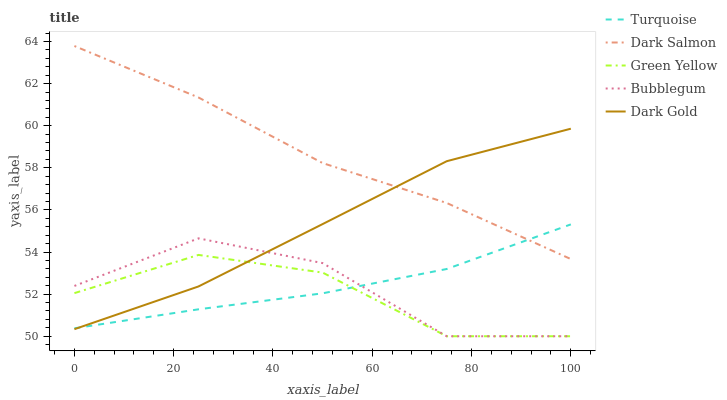Does Green Yellow have the minimum area under the curve?
Answer yes or no. Yes. Does Dark Salmon have the maximum area under the curve?
Answer yes or no. Yes. Does Dark Salmon have the minimum area under the curve?
Answer yes or no. No. Does Green Yellow have the maximum area under the curve?
Answer yes or no. No. Is Turquoise the smoothest?
Answer yes or no. Yes. Is Bubblegum the roughest?
Answer yes or no. Yes. Is Green Yellow the smoothest?
Answer yes or no. No. Is Green Yellow the roughest?
Answer yes or no. No. Does Dark Salmon have the lowest value?
Answer yes or no. No. Does Dark Salmon have the highest value?
Answer yes or no. Yes. Does Green Yellow have the highest value?
Answer yes or no. No. Is Green Yellow less than Dark Salmon?
Answer yes or no. Yes. Is Dark Salmon greater than Bubblegum?
Answer yes or no. Yes. Does Dark Salmon intersect Turquoise?
Answer yes or no. Yes. Is Dark Salmon less than Turquoise?
Answer yes or no. No. Is Dark Salmon greater than Turquoise?
Answer yes or no. No. Does Green Yellow intersect Dark Salmon?
Answer yes or no. No. 